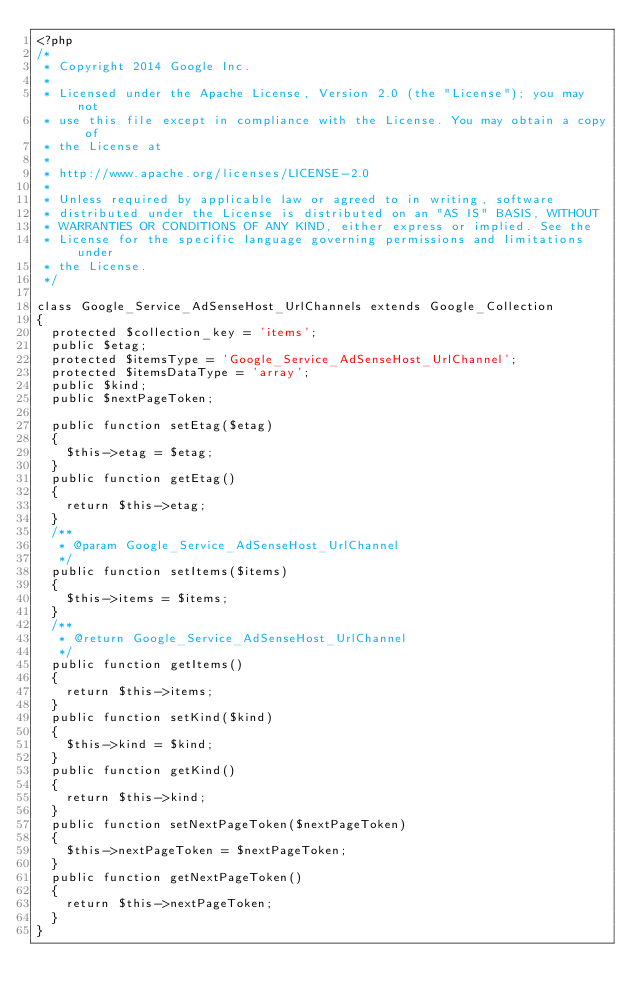<code> <loc_0><loc_0><loc_500><loc_500><_PHP_><?php
/*
 * Copyright 2014 Google Inc.
 *
 * Licensed under the Apache License, Version 2.0 (the "License"); you may not
 * use this file except in compliance with the License. You may obtain a copy of
 * the License at
 *
 * http://www.apache.org/licenses/LICENSE-2.0
 *
 * Unless required by applicable law or agreed to in writing, software
 * distributed under the License is distributed on an "AS IS" BASIS, WITHOUT
 * WARRANTIES OR CONDITIONS OF ANY KIND, either express or implied. See the
 * License for the specific language governing permissions and limitations under
 * the License.
 */

class Google_Service_AdSenseHost_UrlChannels extends Google_Collection
{
  protected $collection_key = 'items';
  public $etag;
  protected $itemsType = 'Google_Service_AdSenseHost_UrlChannel';
  protected $itemsDataType = 'array';
  public $kind;
  public $nextPageToken;

  public function setEtag($etag)
  {
    $this->etag = $etag;
  }
  public function getEtag()
  {
    return $this->etag;
  }
  /**
   * @param Google_Service_AdSenseHost_UrlChannel
   */
  public function setItems($items)
  {
    $this->items = $items;
  }
  /**
   * @return Google_Service_AdSenseHost_UrlChannel
   */
  public function getItems()
  {
    return $this->items;
  }
  public function setKind($kind)
  {
    $this->kind = $kind;
  }
  public function getKind()
  {
    return $this->kind;
  }
  public function setNextPageToken($nextPageToken)
  {
    $this->nextPageToken = $nextPageToken;
  }
  public function getNextPageToken()
  {
    return $this->nextPageToken;
  }
}
</code> 